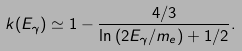<formula> <loc_0><loc_0><loc_500><loc_500>k ( E _ { \gamma } ) \simeq 1 - \frac { 4 / 3 } { \ln { ( 2 E _ { \gamma } / m _ { e } ) } + 1 / 2 } .</formula> 